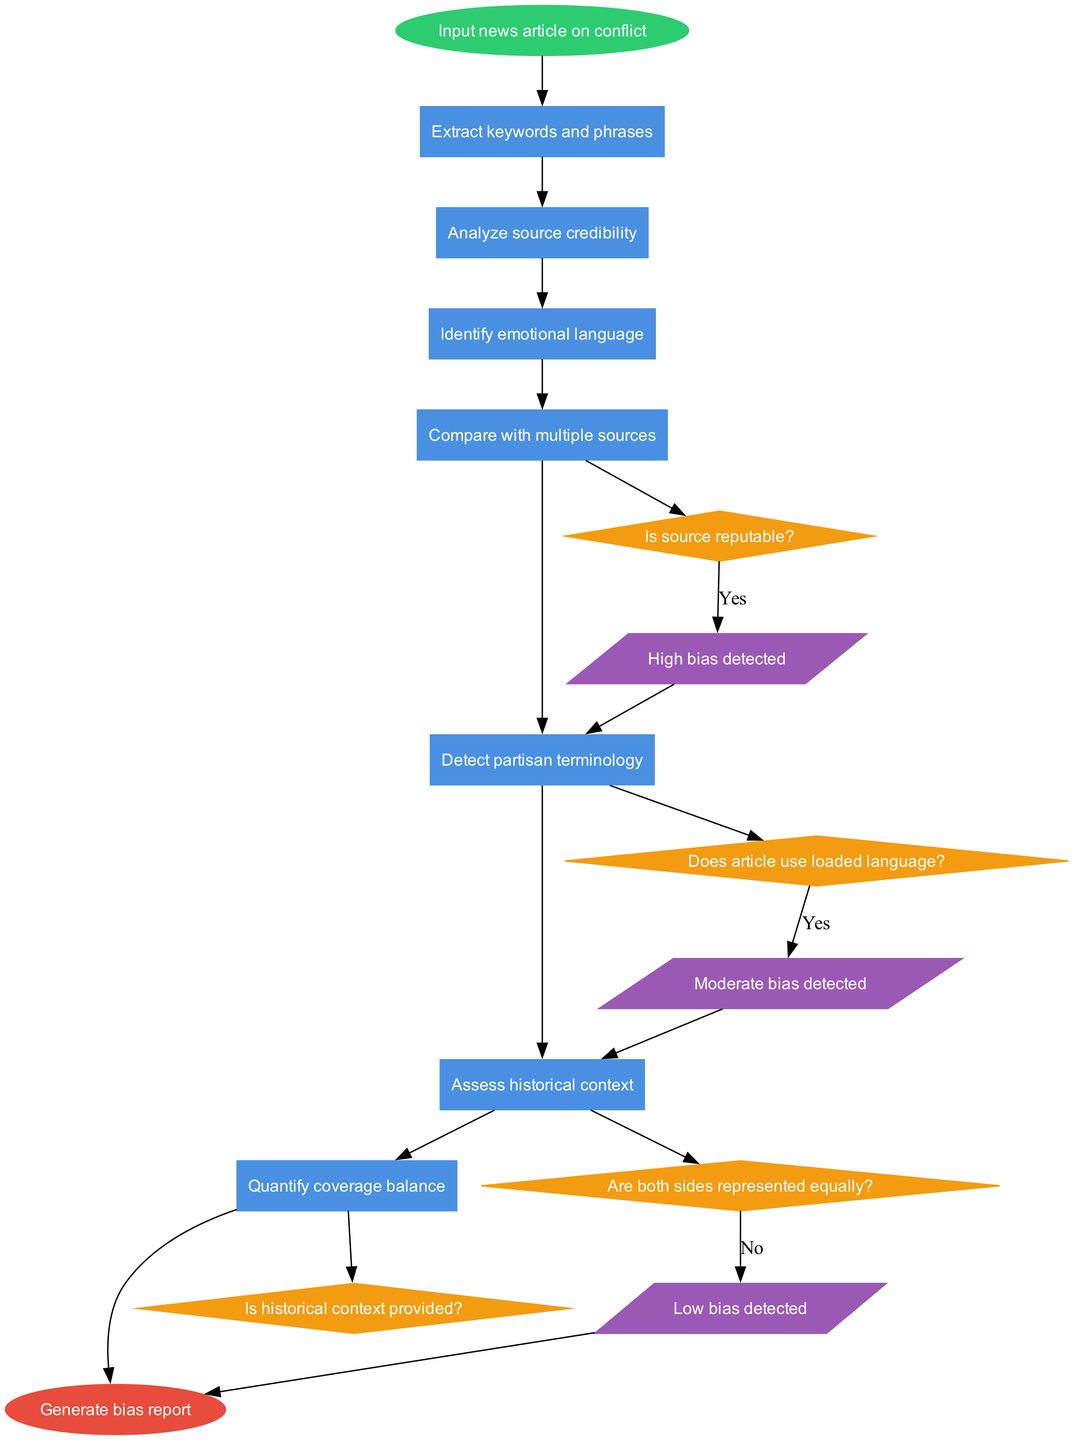What is the first process in the flowchart? The flowchart starts with the node labeled "Input news article on conflict" leading to the process labeled "Extract keywords and phrases." The first process directly follows the start node.
Answer: Extract keywords and phrases How many decision nodes are present in the diagram? By counting the diamond-shaped nodes labeled as decisions, there are a total of four decision nodes in the diagram. Each decision relates to credibility or representation in the articles.
Answer: Four What does the decision node labeled "Is source reputable?" lead to? The decision node "Is source reputable?" connects to one of the output nodes based on the answer, specifically leading to the outputs related to bias detection if affirmed. This wraps into the flow of assessing the credibility of sources.
Answer: High bias detected Which output follows the decision question "Are both sides represented equally?" if the answer is 'No'? In the flowchart, the decision "Are both sides represented equally?" leads to the output labeled "High bias detected" if the answer is 'No'. This indicates a direct assessment of balance in conflict reporting.
Answer: High bias detected After which process do we assess the historical context? The historical context is assessed after the process of "Detect partisan terminology." The flow flows through to this assessment step, indicating that it's considered after identifying biases in language used.
Answer: Detect partisan terminology What are the three possible outputs from the bias analysis? The three outputs from the bias analysis are labeled as "High bias detected," "Moderate bias detected," and "Low bias detected," which categorize the level of bias found in the analyzed article.
Answer: High bias detected, Moderate bias detected, Low bias detected Which process comes right before the assessment of emotional language? The process "Analyze source credibility" comes right before the assessment of "Identify emotional language." This suggests that credibility should be evaluated before further emotional context.
Answer: Analyze source credibility What is the last process in the flowchart before generating a bias report? The last process before reaching the end node and generating the bias report is "Quantify coverage balance." This is the final analysis step that underpins the final report's conclusions.
Answer: Quantify coverage balance 